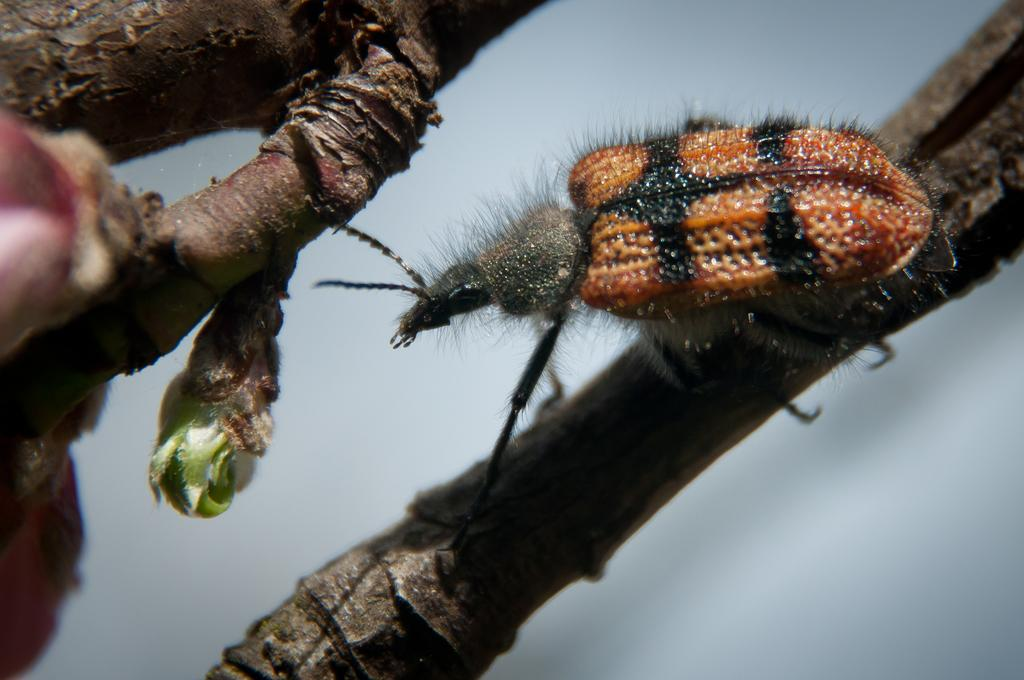What type of plant is visible in the image? The image contains branches of a plant. Are there any living organisms present in the image? Yes, there is an insect in the image. Can you describe a specific part of the plant in the image? There is a bud on the left side of the image. What type of floor can be seen in the image? There is no floor present in the image; it features branches of a plant and an insect. 